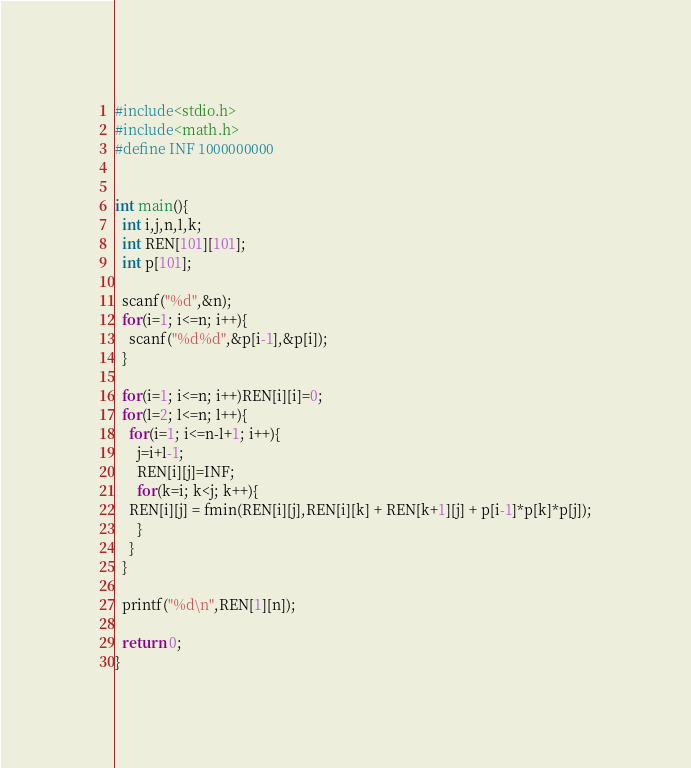Convert code to text. <code><loc_0><loc_0><loc_500><loc_500><_C_>#include<stdio.h>
#include<math.h>
#define INF 1000000000


int main(){
  int i,j,n,l,k;
  int REN[101][101];
  int p[101];
  
  scanf("%d",&n);
  for(i=1; i<=n; i++){
    scanf("%d%d",&p[i-1],&p[i]);
  }
  
  for(i=1; i<=n; i++)REN[i][i]=0;
  for(l=2; l<=n; l++){
    for(i=1; i<=n-l+1; i++){
      j=i+l-1;
      REN[i][j]=INF;
      for(k=i; k<j; k++){
	REN[i][j] = fmin(REN[i][j],REN[i][k] + REN[k+1][j] + p[i-1]*p[k]*p[j]);
      }
    }
  }
  
  printf("%d\n",REN[1][n]);
  
  return 0;
}

</code> 